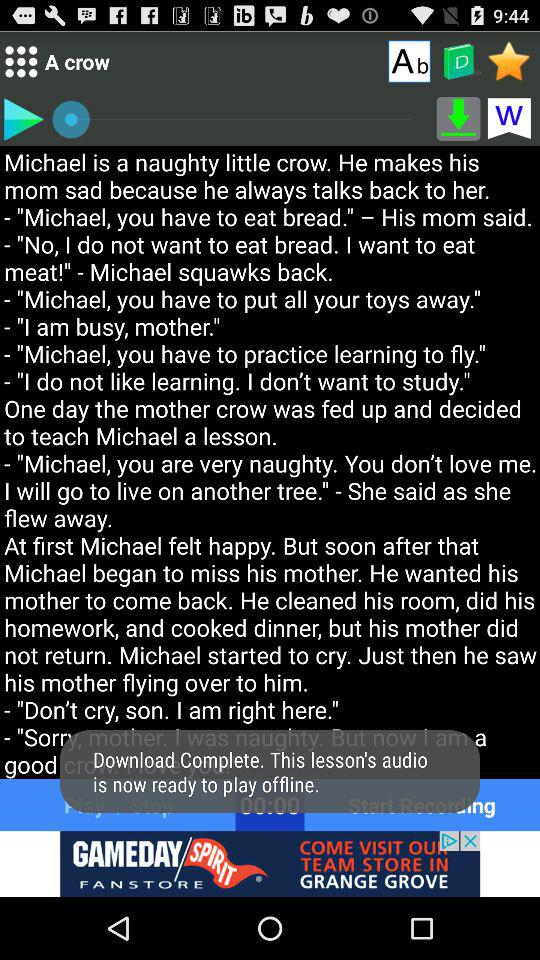What is the mentioned duration? The mentioned duration is 00:00. 